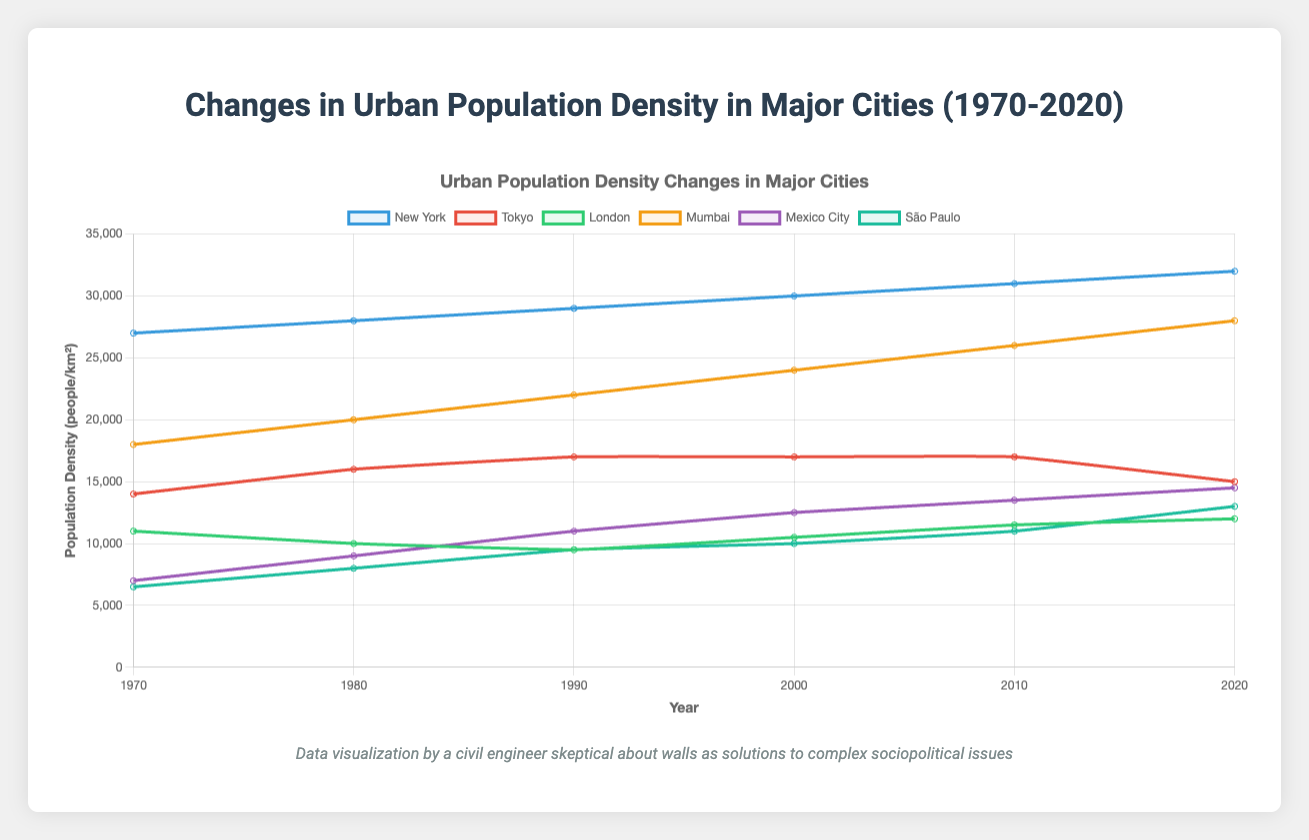Which city had the highest urban population density in 1970? By referring to the figure, the highest line in 1970 corresponds to New York with 27,000 people/km².
Answer: New York Which city had the lowest urban population density in 2020? The lowest line in 2020 corresponds to São Paulo with a density of 13,000 people/km².
Answer: São Paulo What's the difference in urban population density between New York and Tokyo in 2020? In 2020, New York had a density of 32,000 people/km² and Tokyo had 15,000 people/km². The difference is 32,000 - 15,000 = 17,000 people/km².
Answer: 17,000 people/km² Which city experienced the greatest increase in urban population density from 1970 to 2020? Mumbai's population density increased from 18,000 people/km² in 1970 to 28,000 people/km² in 2020, which is an increase of 10,000 people/km², higher than any other city shown.
Answer: Mumbai How did the urban population density of London change from 1970 to 2020? London's population density decreased from 11,000 people/km² in 1970 to 10,000 people/km² by 1990 but then increased again to 12,000 people/km² by 2020.
Answer: Decrease, then increase Which city showed a steady urban population density most years? Tokyo's urban population density showed the least variation, remaining constant at 17,000 people/km² from 1990 to 2010 before slightly decreasing in 2020.
Answer: Tokyo 